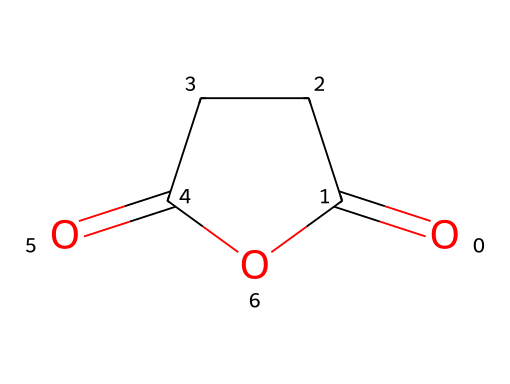What is the name of this chemical? The chemical structure corresponds to the compound known as succinic anhydride, which is derived from succinic acid by dehydration.
Answer: succinic anhydride How many carbon atoms are in this chemical? By examining the structure, there are four carbon atoms (C) in the structure of succinic anhydride.
Answer: 4 What functional groups are present in this chemical? The structure shows that succinic anhydride contains an anhydride functional group, characterized by the presence of two carbonyl groups linked by a carbon chain.
Answer: anhydride What type of compound is this? Given the structure and the presence of the anhydride functional group, it can be classified as an acid anhydride, which is formed from carboxylic acids.
Answer: acid anhydride What is the molecular formula of this chemical? Counting the atoms present in the structure: C4, H4, and O3 gives the molecular formula C4H4O3 for succinic anhydride.
Answer: C4H4O3 How many double bonds are present in this chemical? Reviewing the structure, there are two double bonds where the carbonyl groups (C=O) are present, indicating the presence of two double bonds in succinic anhydride.
Answer: 2 What is the total degree of unsaturation in this chemical? The degree of unsaturation can be determined by the formula (1 + C - H/2 + N/2 + X/2). For succinic anhydride, substituting its values gives a degree of unsaturation of 3.
Answer: 3 